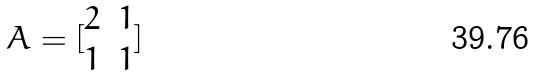<formula> <loc_0><loc_0><loc_500><loc_500>A = [ \begin{matrix} 2 & 1 \\ 1 & 1 \end{matrix} ]</formula> 